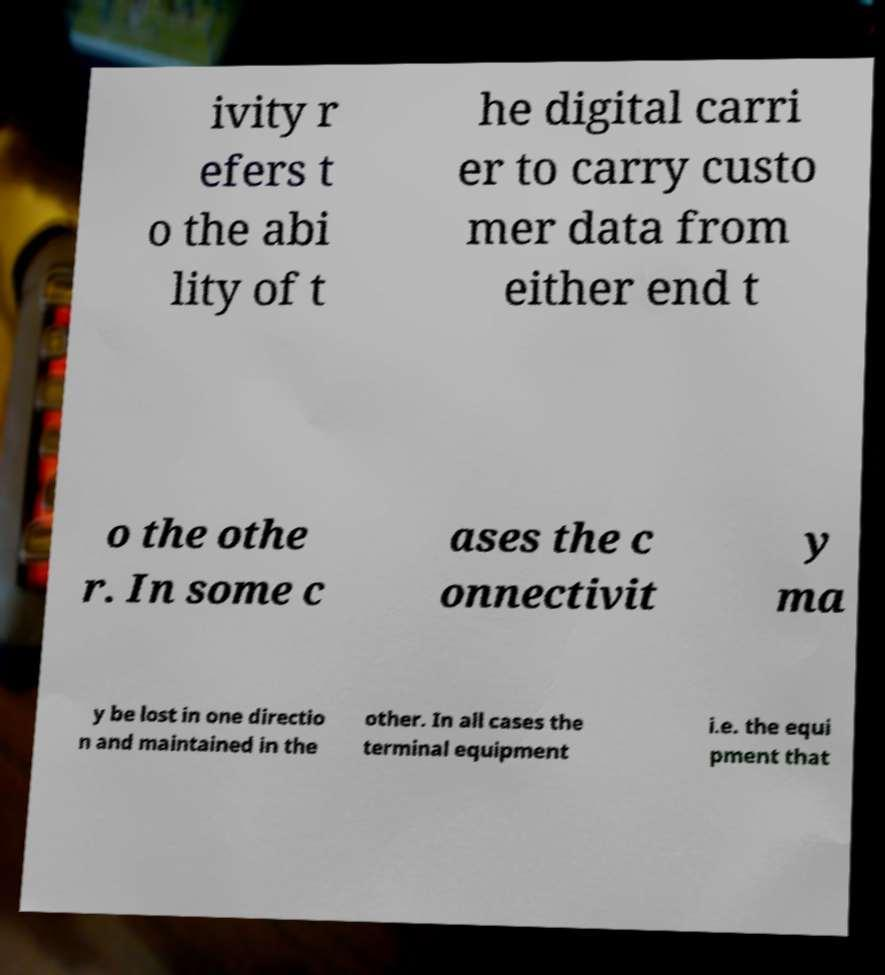I need the written content from this picture converted into text. Can you do that? ivity r efers t o the abi lity of t he digital carri er to carry custo mer data from either end t o the othe r. In some c ases the c onnectivit y ma y be lost in one directio n and maintained in the other. In all cases the terminal equipment i.e. the equi pment that 